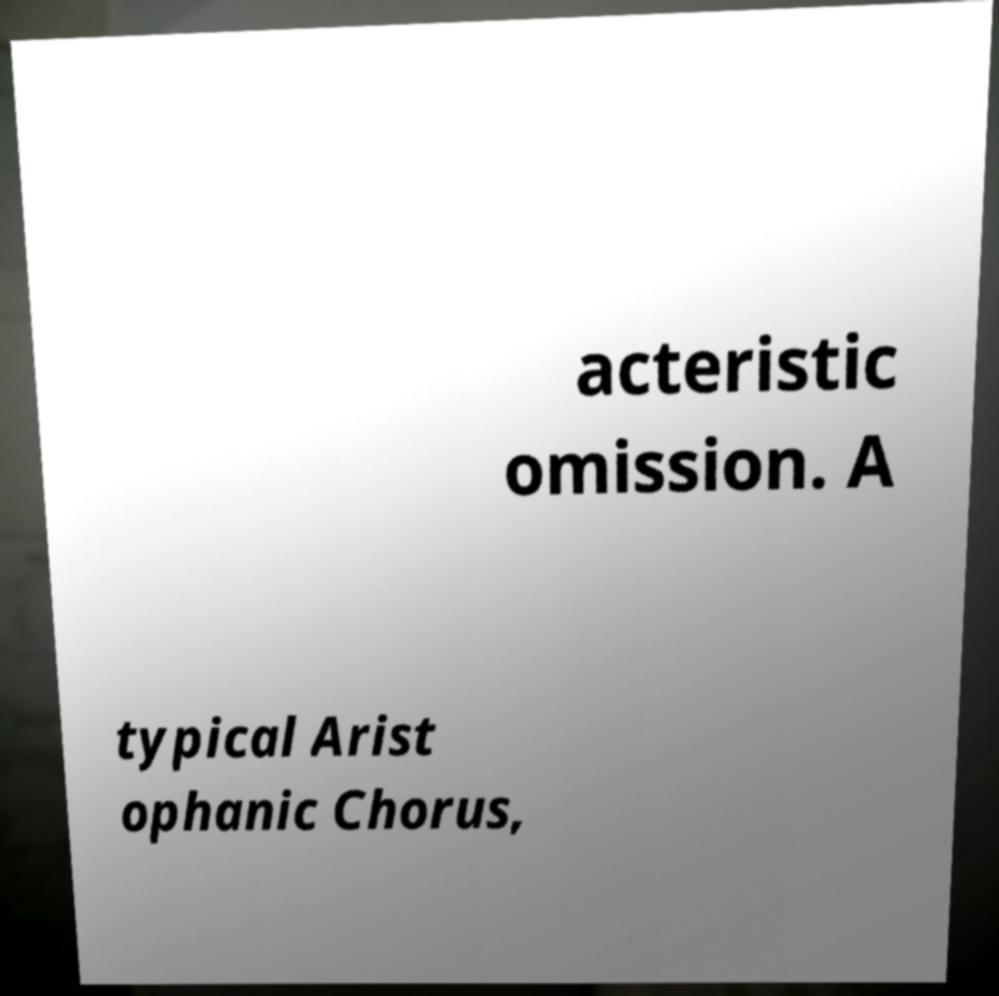Can you read and provide the text displayed in the image?This photo seems to have some interesting text. Can you extract and type it out for me? acteristic omission. A typical Arist ophanic Chorus, 